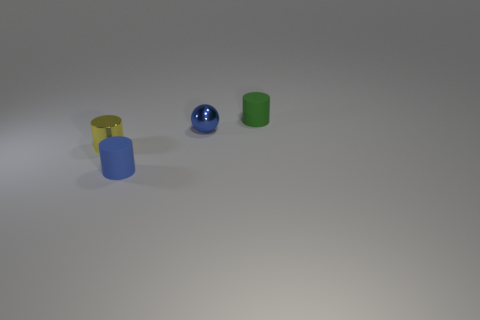Add 2 tiny blue objects. How many objects exist? 6 Subtract all cylinders. How many objects are left? 1 Subtract 0 red cylinders. How many objects are left? 4 Subtract all gray rubber cylinders. Subtract all tiny yellow objects. How many objects are left? 3 Add 3 yellow metal objects. How many yellow metal objects are left? 4 Add 1 green things. How many green things exist? 2 